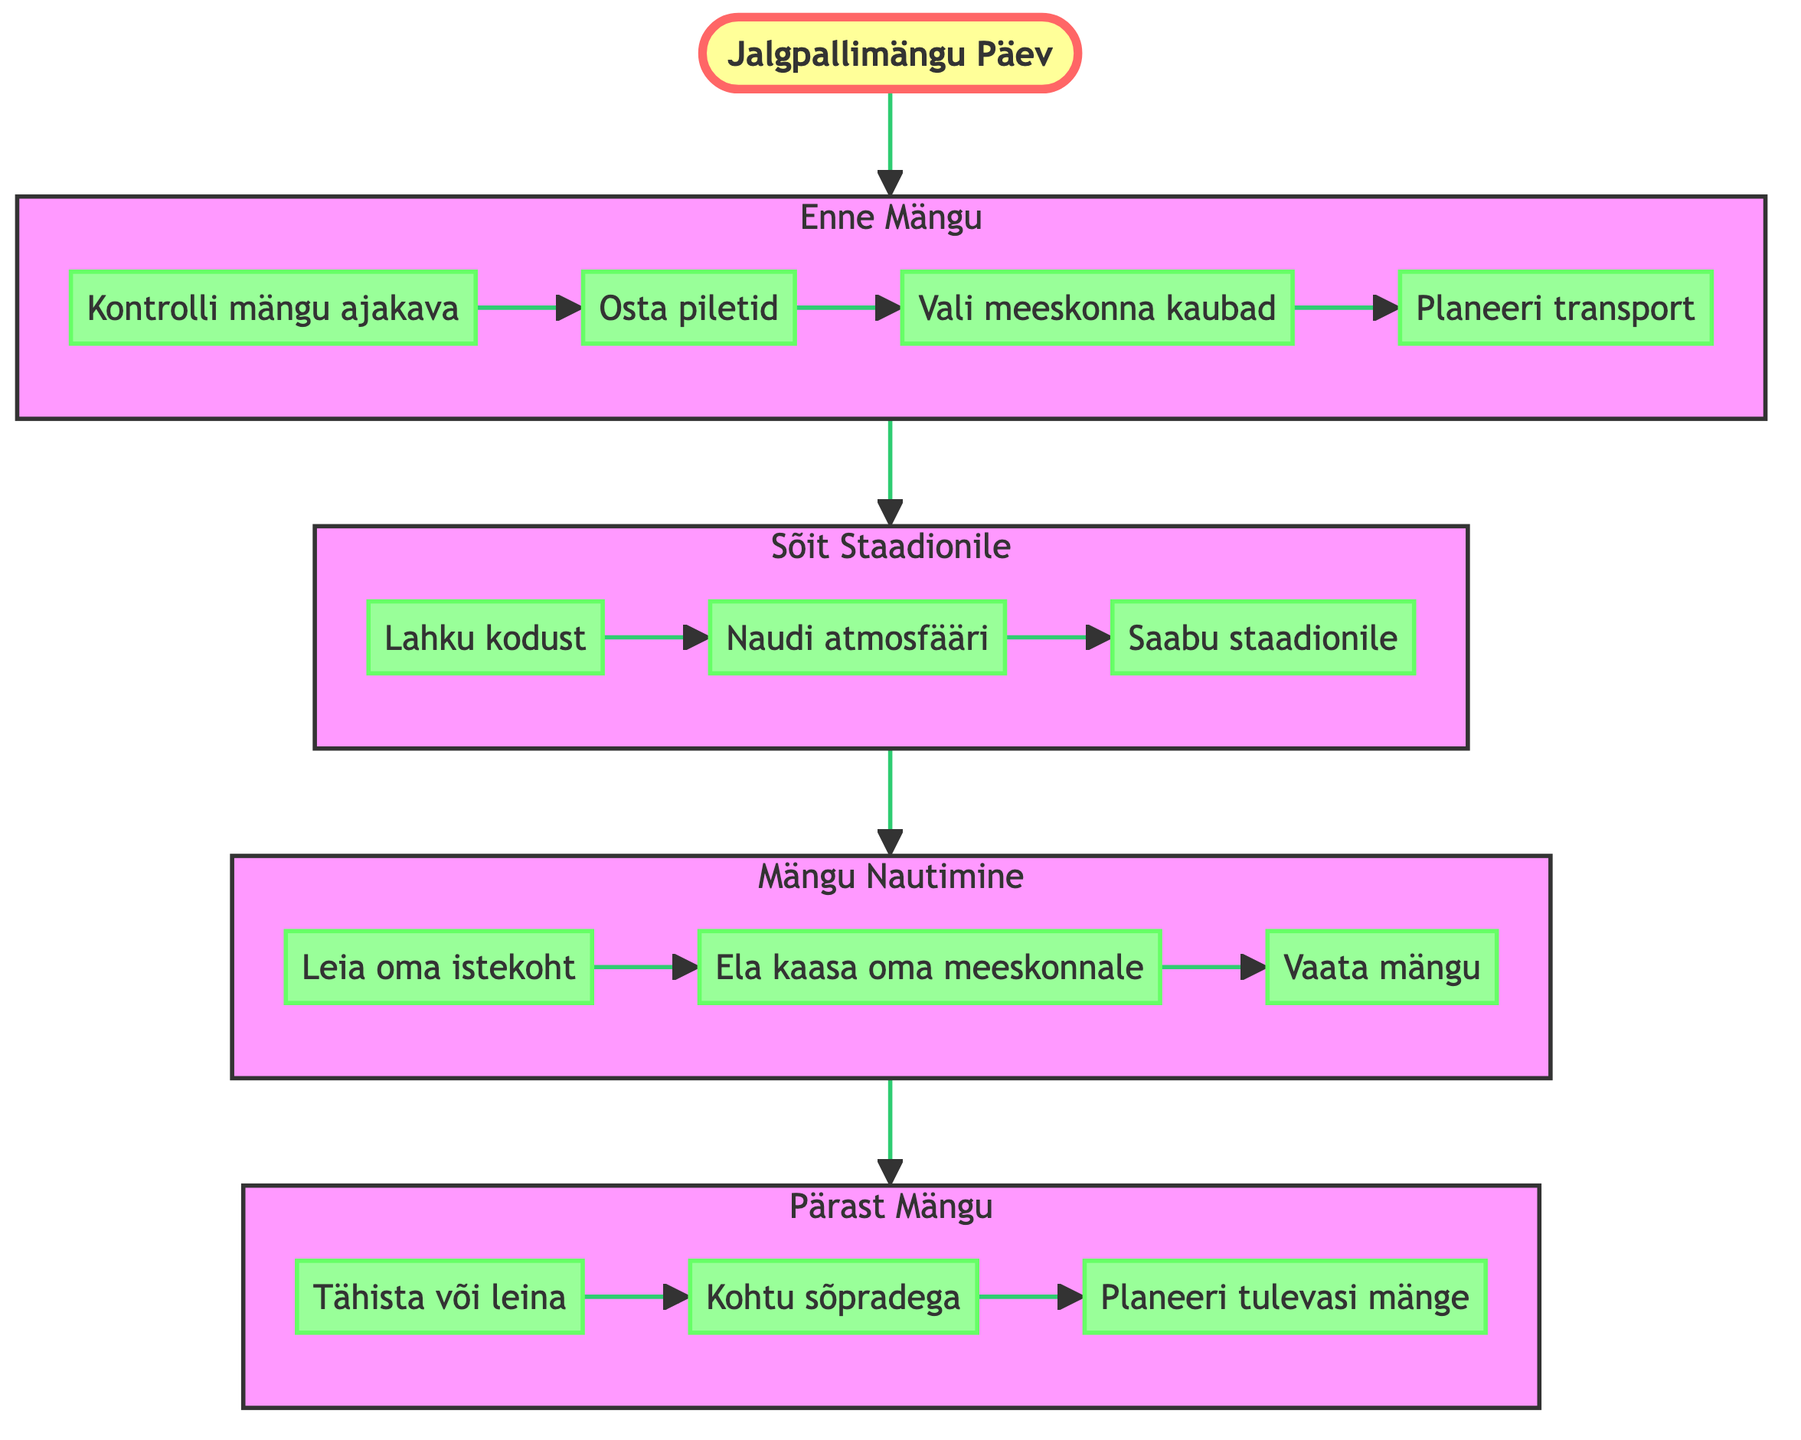What is the first activity in the PreMatch stage? The first activity listed in the PreMatch stage is "Check Match Schedule". This can be identified by looking at the nodes under the PreMatch subgraph and observing the order in which they are represented.
Answer: Check Match Schedule How many activities are there in the Match stage? The Match stage contains three activities: "Find Your Seat", "Cheer for Your Team", and "Watch the Game". By counting each node in the Match subgraph, we find there are three listed activities.
Answer: 3 Which activity comes after "Leave Home" in the Travel stage? The activity that follows "Leave Home" is "Enjoy the Atmosphere". This can be determined by following the arrows connecting the nodes in the Travel subgraph and observing the sequence.
Answer: Enjoy the Atmosphere What is the last activity in the PostMatch stage? The last activity in the PostMatch stage is "Plan Future Matches". This can be deduced by looking at the sequence of activities in the PostMatch subgraph and identifying the last node.
Answer: Plan Future Matches What flow connects the Travel and Match stages? The flow connecting the Travel stage to the Match stage is represented by an arrow that points from Travel to Match. This indicates the progression from traveling to the stadium to the enjoyment of the match.
Answer: Arrow How many total stages are there in the diagram? The diagram consists of four main stages: PreMatch, Travel, Match, and PostMatch. By counting each of these distinct sections helps determine the total number of stages represented.
Answer: 4 What is the purpose of the "Celebrate or Commiserate" activity? The purpose of the "Celebrate or Commiserate" activity is to express joy or disappointment based on the match outcome. This is indicated in the description associated with this particular node in the PostMatch stage.
Answer: Express joy or disappointment Which activity precedes "Arrive at Stadium"? The activity that comes right before "Arrive at Stadium" is "Enjoy the Atmosphere". This relationship can be established by checking the order of activities in the Travel subgraph.
Answer: Enjoy the Atmosphere 